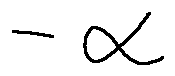Convert formula to latex. <formula><loc_0><loc_0><loc_500><loc_500>- \alpha</formula> 